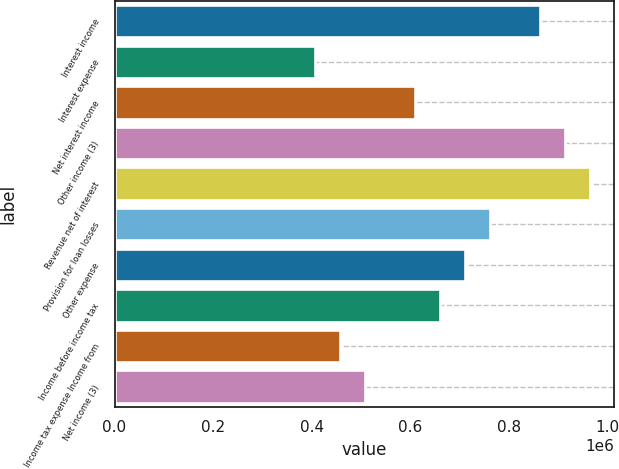Convert chart. <chart><loc_0><loc_0><loc_500><loc_500><bar_chart><fcel>Interest income<fcel>Interest expense<fcel>Net interest income<fcel>Other income (3)<fcel>Revenue net of interest<fcel>Provision for loan losses<fcel>Other expense<fcel>Income before income tax<fcel>Income tax expense Income from<fcel>Net income (3)<nl><fcel>863442<fcel>406326<fcel>609488<fcel>914233<fcel>965023<fcel>761860<fcel>711070<fcel>660279<fcel>457116<fcel>507907<nl></chart> 